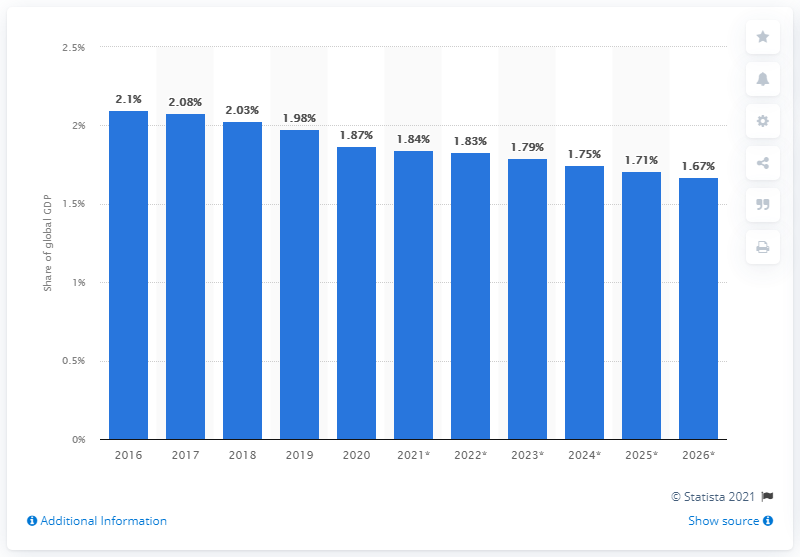Indicate a few pertinent items in this graphic. In 2020, Italy's share of GDP was 1.87. 